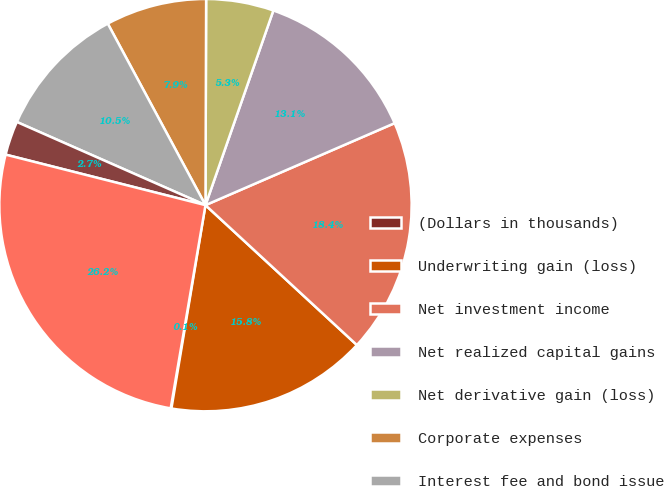Convert chart to OTSL. <chart><loc_0><loc_0><loc_500><loc_500><pie_chart><fcel>(Dollars in thousands)<fcel>Underwriting gain (loss)<fcel>Net investment income<fcel>Net realized capital gains<fcel>Net derivative gain (loss)<fcel>Corporate expenses<fcel>Interest fee and bond issue<fcel>Other income (expense)<fcel>Income (loss) before taxes<nl><fcel>0.06%<fcel>15.77%<fcel>18.38%<fcel>13.15%<fcel>5.29%<fcel>7.91%<fcel>10.53%<fcel>2.67%<fcel>26.24%<nl></chart> 